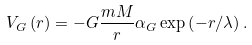<formula> <loc_0><loc_0><loc_500><loc_500>V _ { G } \left ( r \right ) = - G \frac { m M } { r } \alpha _ { G } \exp \left ( - r / \lambda \right ) .</formula> 